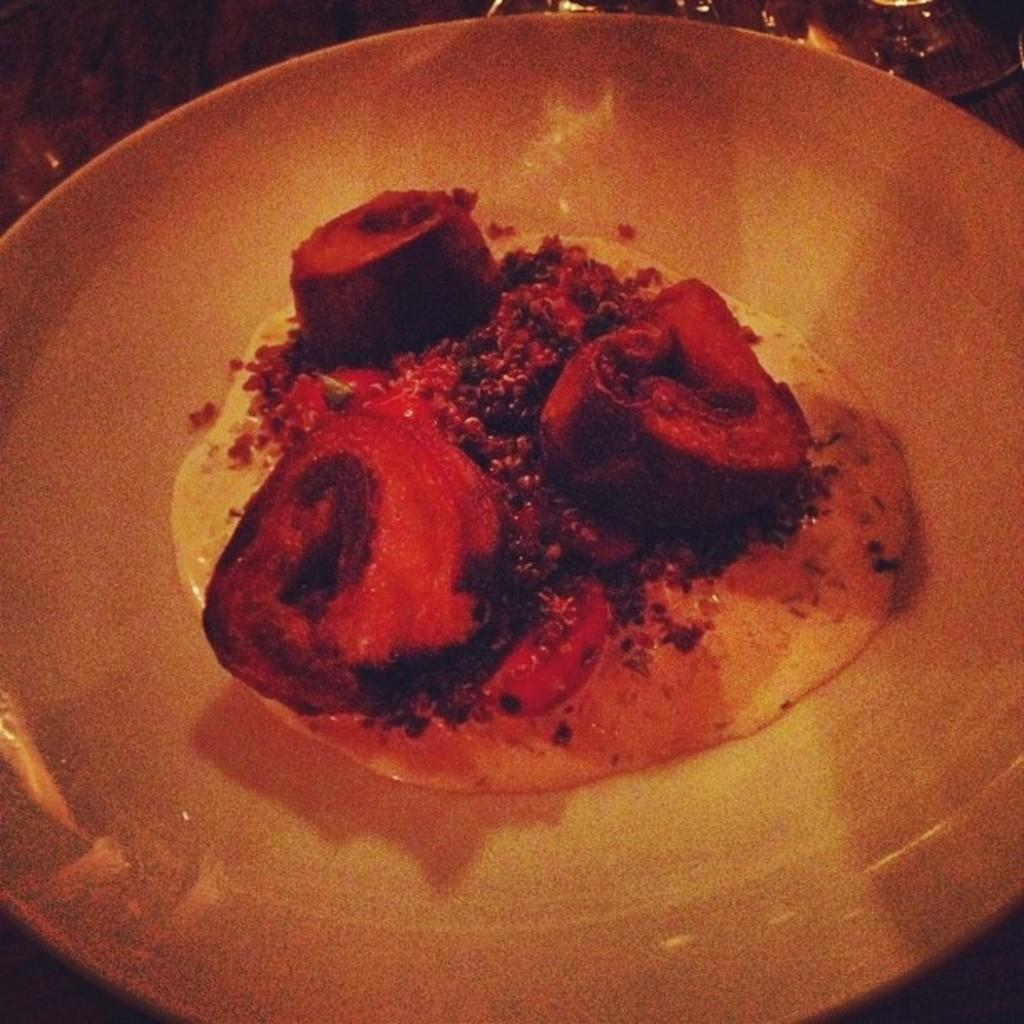What is on the plate in the image? There is food on the plate in the image. What else can be seen in the image besides the plate? There are glasses visible behind the plate. What type of songs can be heard coming from the throne in the image? There is no throne present in the image, so it's not possible to determine what, if any, songs might be heard. 